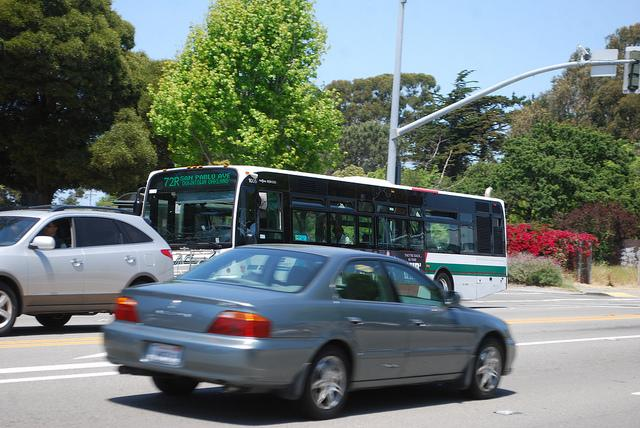How many directions are the vehicles shown going in? Please explain your reasoning. two. The car in the foreground is travelling right. in the background another car and a bus are travelling left. 